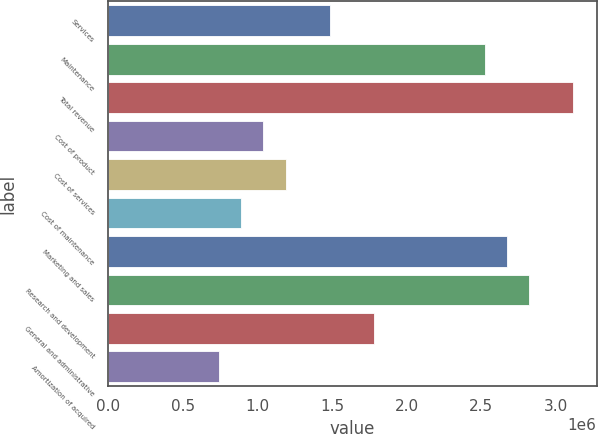Convert chart to OTSL. <chart><loc_0><loc_0><loc_500><loc_500><bar_chart><fcel>Services<fcel>Maintenance<fcel>Total revenue<fcel>Cost of product<fcel>Cost of services<fcel>Cost of maintenance<fcel>Marketing and sales<fcel>Research and development<fcel>General and administrative<fcel>Amortization of acquired<nl><fcel>1.48389e+06<fcel>2.52262e+06<fcel>3.11618e+06<fcel>1.03873e+06<fcel>1.18712e+06<fcel>890337<fcel>2.67101e+06<fcel>2.8194e+06<fcel>1.78067e+06<fcel>741948<nl></chart> 